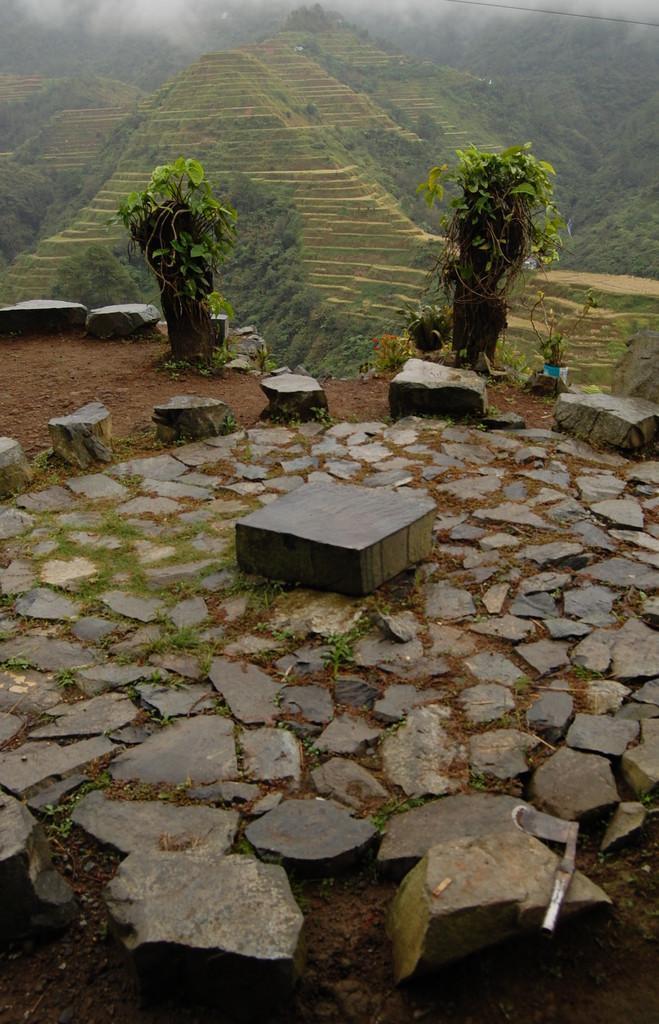How would you summarize this image in a sentence or two? In this image, we can see stones and plants. In the background, we can see hills. 